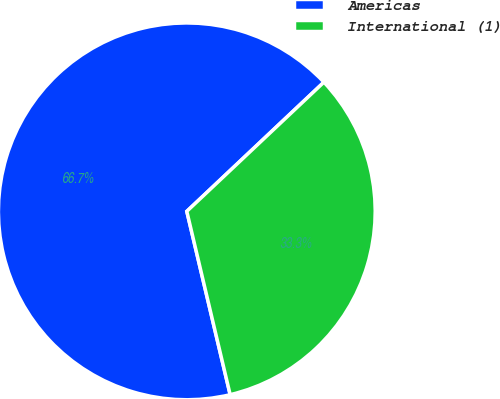<chart> <loc_0><loc_0><loc_500><loc_500><pie_chart><fcel>Americas<fcel>International (1)<nl><fcel>66.67%<fcel>33.33%<nl></chart> 